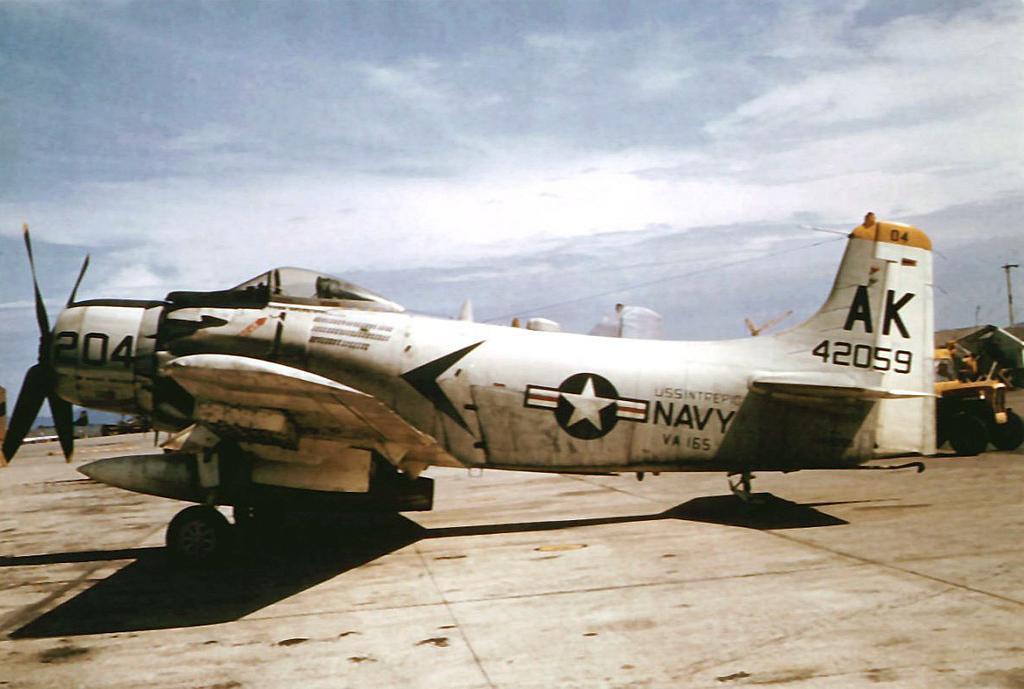Could you give a brief overview of what you see in this image? In this image, there is a white color aircraft, on that there is NAVY written, at the top there is a sky. 